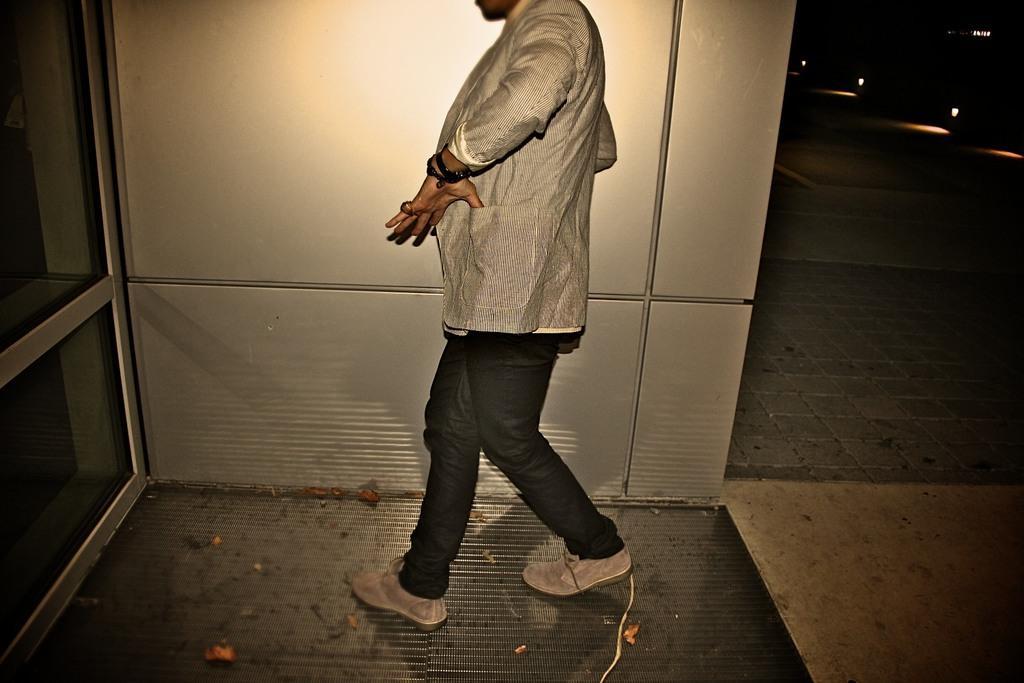How would you summarize this image in a sentence or two? In the center of the picture there is a person. On the left there is a glass window. On the right there are lights and floor. At the bottom there are dry leaves. 